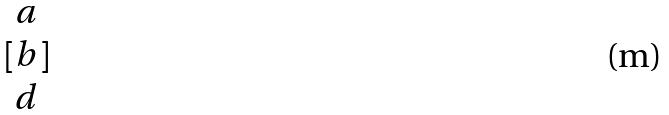<formula> <loc_0><loc_0><loc_500><loc_500>[ \begin{matrix} a \\ b \\ d \end{matrix} ]</formula> 